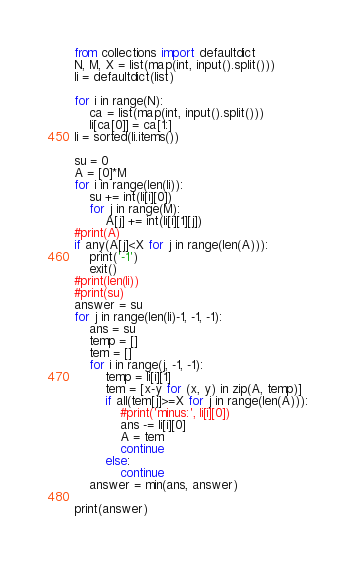<code> <loc_0><loc_0><loc_500><loc_500><_Python_>from collections import defaultdict
N, M, X = list(map(int, input().split()))
li = defaultdict(list)

for i in range(N):
    ca = list(map(int, input().split()))
    li[ca[0]] = ca[1:]
li = sorted(li.items())

su = 0
A = [0]*M
for i in range(len(li)):
    su += int(li[i][0])
    for j in range(M):
        A[j] += int(li[i][1][j])
#print(A)
if any(A[j]<X for j in range(len(A))):
    print('-1')
    exit()
#print(len(li))
#print(su)
answer = su
for j in range(len(li)-1, -1, -1):
    ans = su
    temp = []
    tem = []
    for i in range(j, -1, -1):
        temp = li[i][1]
        tem = [x-y for (x, y) in zip(A, temp)]
        if all(tem[j]>=X for j in range(len(A))):
            #print('minus:', li[i][0])
            ans -= li[i][0]
            A = tem
            continue
        else:
            continue
    answer = min(ans, answer)

print(answer)</code> 